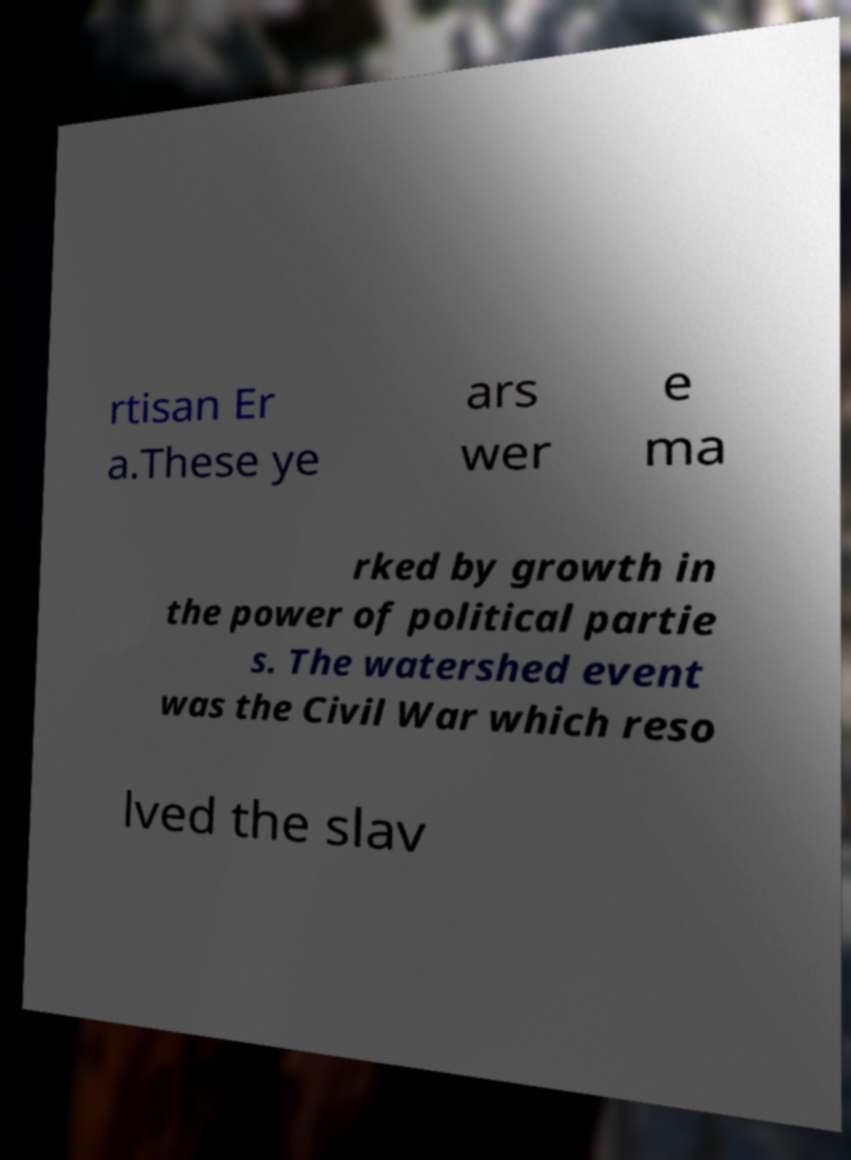Could you assist in decoding the text presented in this image and type it out clearly? rtisan Er a.These ye ars wer e ma rked by growth in the power of political partie s. The watershed event was the Civil War which reso lved the slav 